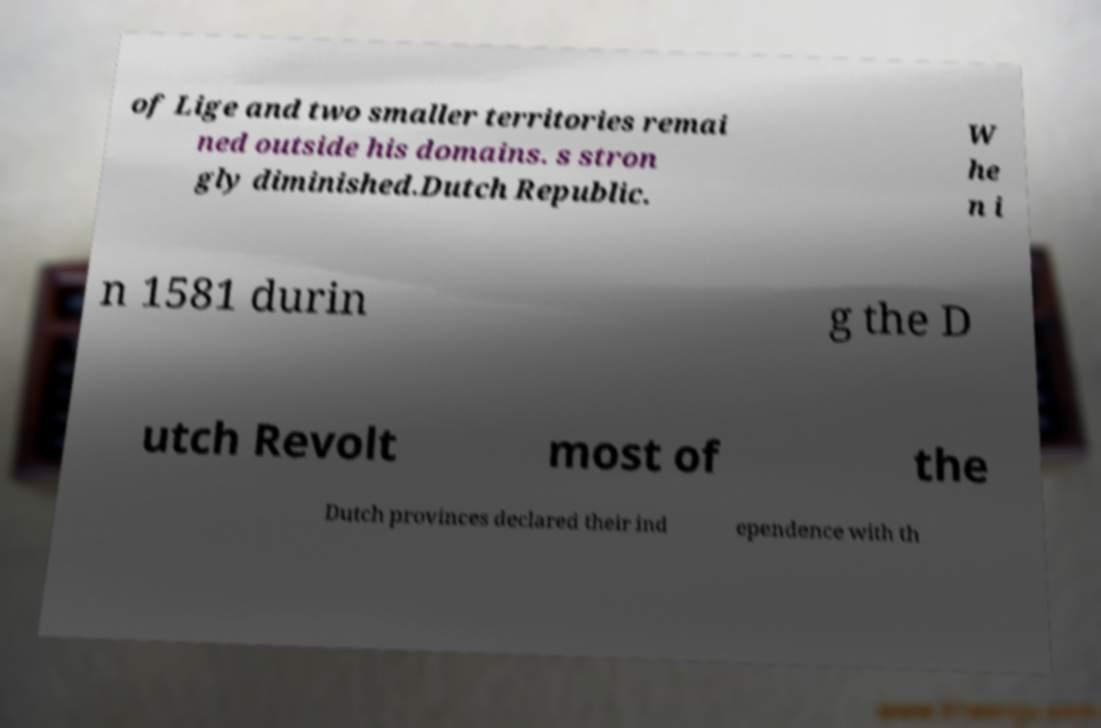Can you accurately transcribe the text from the provided image for me? of Lige and two smaller territories remai ned outside his domains. s stron gly diminished.Dutch Republic. W he n i n 1581 durin g the D utch Revolt most of the Dutch provinces declared their ind ependence with th 